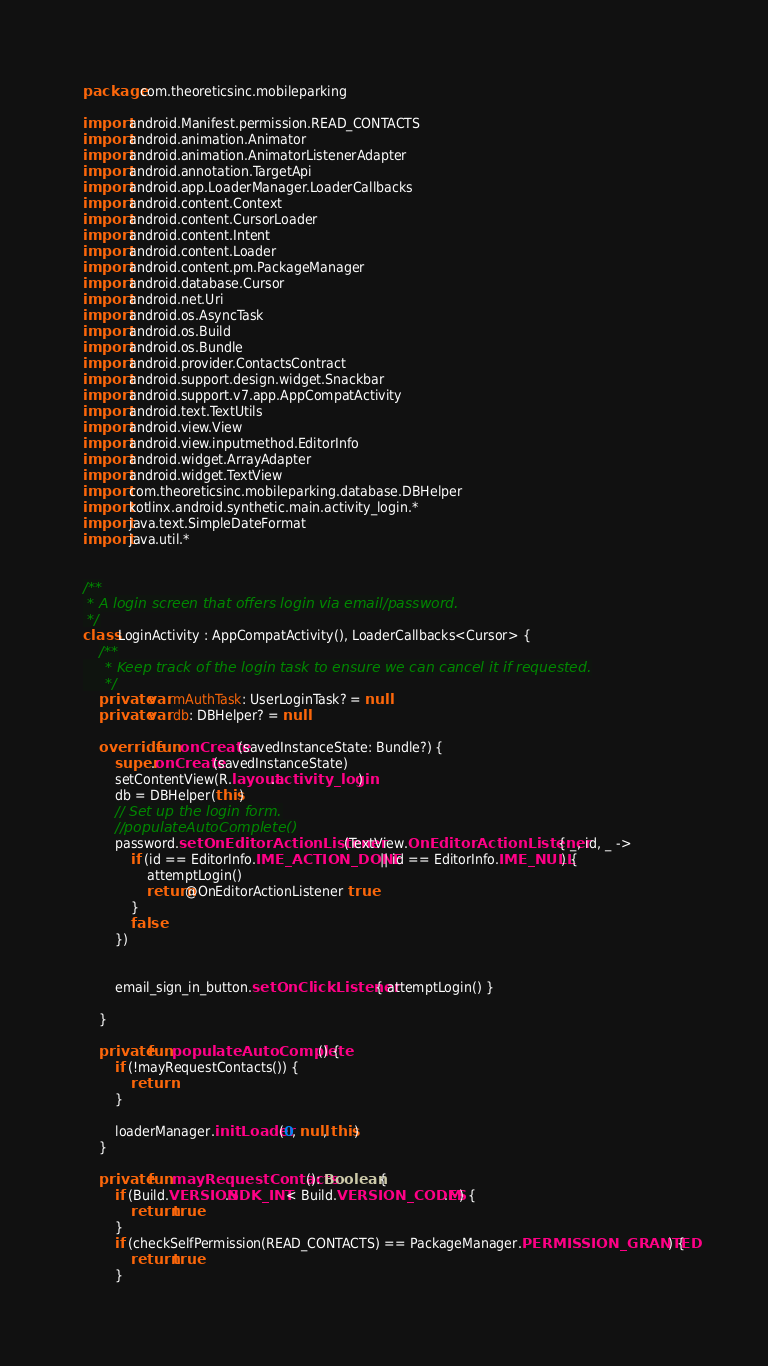Convert code to text. <code><loc_0><loc_0><loc_500><loc_500><_Kotlin_>package com.theoreticsinc.mobileparking

import android.Manifest.permission.READ_CONTACTS
import android.animation.Animator
import android.animation.AnimatorListenerAdapter
import android.annotation.TargetApi
import android.app.LoaderManager.LoaderCallbacks
import android.content.Context
import android.content.CursorLoader
import android.content.Intent
import android.content.Loader
import android.content.pm.PackageManager
import android.database.Cursor
import android.net.Uri
import android.os.AsyncTask
import android.os.Build
import android.os.Bundle
import android.provider.ContactsContract
import android.support.design.widget.Snackbar
import android.support.v7.app.AppCompatActivity
import android.text.TextUtils
import android.view.View
import android.view.inputmethod.EditorInfo
import android.widget.ArrayAdapter
import android.widget.TextView
import com.theoreticsinc.mobileparking.database.DBHelper
import kotlinx.android.synthetic.main.activity_login.*
import java.text.SimpleDateFormat
import java.util.*


/**
 * A login screen that offers login via email/password.
 */
class LoginActivity : AppCompatActivity(), LoaderCallbacks<Cursor> {
    /**
     * Keep track of the login task to ensure we can cancel it if requested.
     */
    private var mAuthTask: UserLoginTask? = null
    private var db: DBHelper? = null

    override fun onCreate(savedInstanceState: Bundle?) {
        super.onCreate(savedInstanceState)
        setContentView(R.layout.activity_login)
        db = DBHelper(this)
        // Set up the login form.
        //populateAutoComplete()
        password.setOnEditorActionListener(TextView.OnEditorActionListener { _, id, _ ->
            if (id == EditorInfo.IME_ACTION_DONE || id == EditorInfo.IME_NULL) {
                attemptLogin()
                return@OnEditorActionListener true
            }
            false
        })


        email_sign_in_button.setOnClickListener { attemptLogin() }

    }

    private fun populateAutoComplete() {
        if (!mayRequestContacts()) {
            return
        }

        loaderManager.initLoader(0, null, this)
    }

    private fun mayRequestContacts(): Boolean {
        if (Build.VERSION.SDK_INT < Build.VERSION_CODES.M) {
            return true
        }
        if (checkSelfPermission(READ_CONTACTS) == PackageManager.PERMISSION_GRANTED) {
            return true
        }</code> 